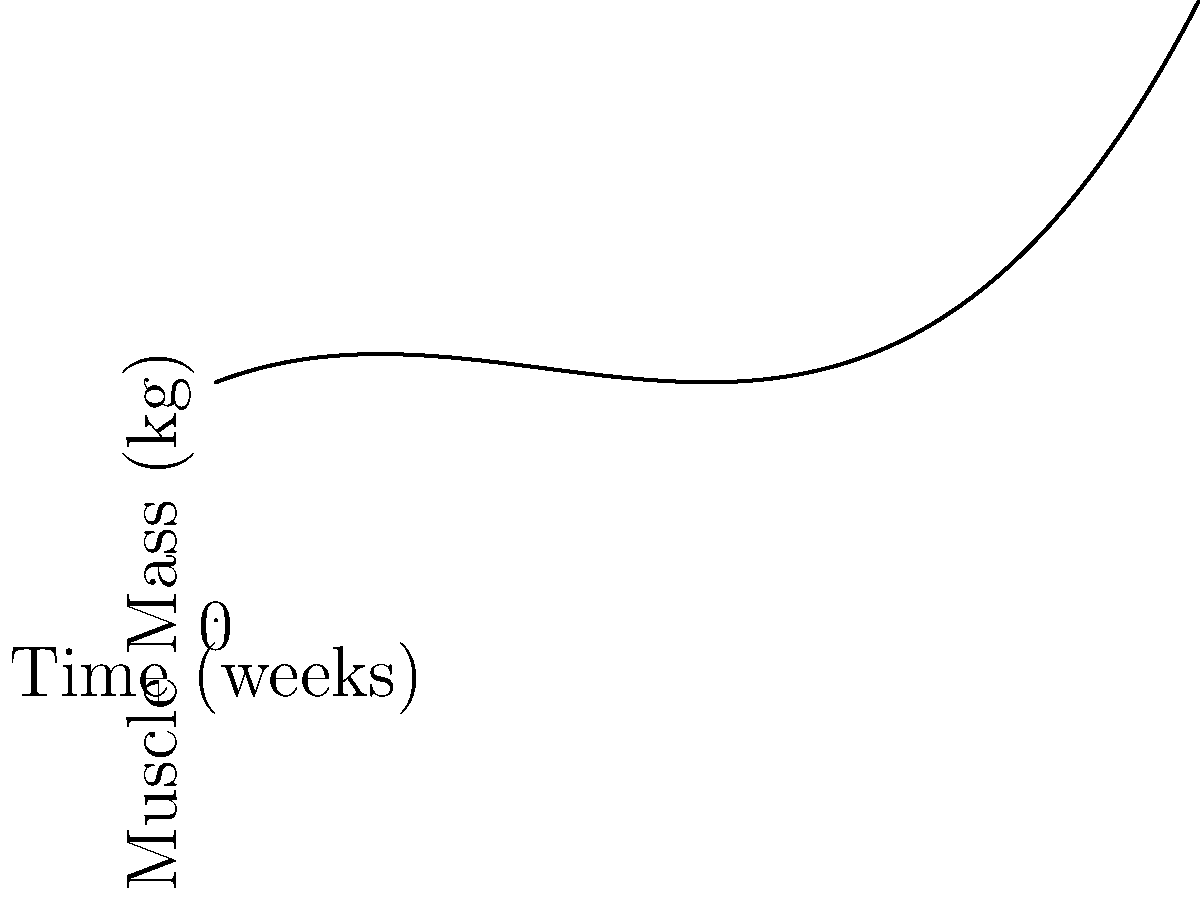The graph shows your muscle mass growth curve during a new training regimen. At point A, your muscle mass is increasing at a rate of 1 kg per week. At point B, the rate of change is 7 kg per week. What is the average rate of change of your muscle mass between points A and B? To solve this problem, we need to follow these steps:

1) First, we need to identify the coordinates of points A and B.
   Point A is at x = 1 week
   Point B is at x = 3 weeks

2) We need to calculate the muscle mass at these points:
   At A: $f(1) = 0.5(1)^3 - 2(1)^2 + 2(1) + 5 = 5.5$ kg
   At B: $f(3) = 0.5(3)^3 - 2(3)^2 + 2(3) + 5 = 14.5$ kg

3) The average rate of change is given by the formula:
   $$\text{Average rate of change} = \frac{\text{Change in y}}{\text{Change in x}} = \frac{f(3) - f(1)}{3 - 1}$$

4) Plugging in the values:
   $$\text{Average rate of change} = \frac{14.5 - 5.5}{3 - 1} = \frac{9}{2} = 4.5$$

Therefore, the average rate of change of your muscle mass between points A and B is 4.5 kg per week.
Answer: 4.5 kg/week 